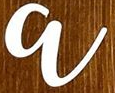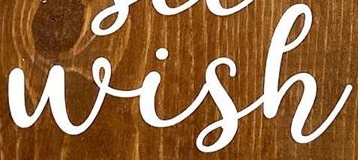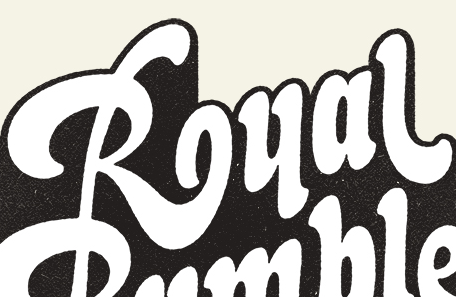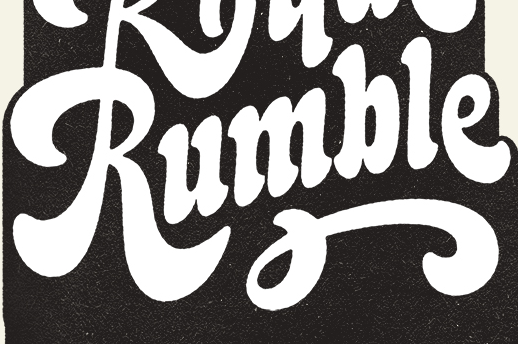What words are shown in these images in order, separated by a semicolon? a; Wish; Rual; Rumble 